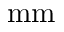<formula> <loc_0><loc_0><loc_500><loc_500>m m</formula> 